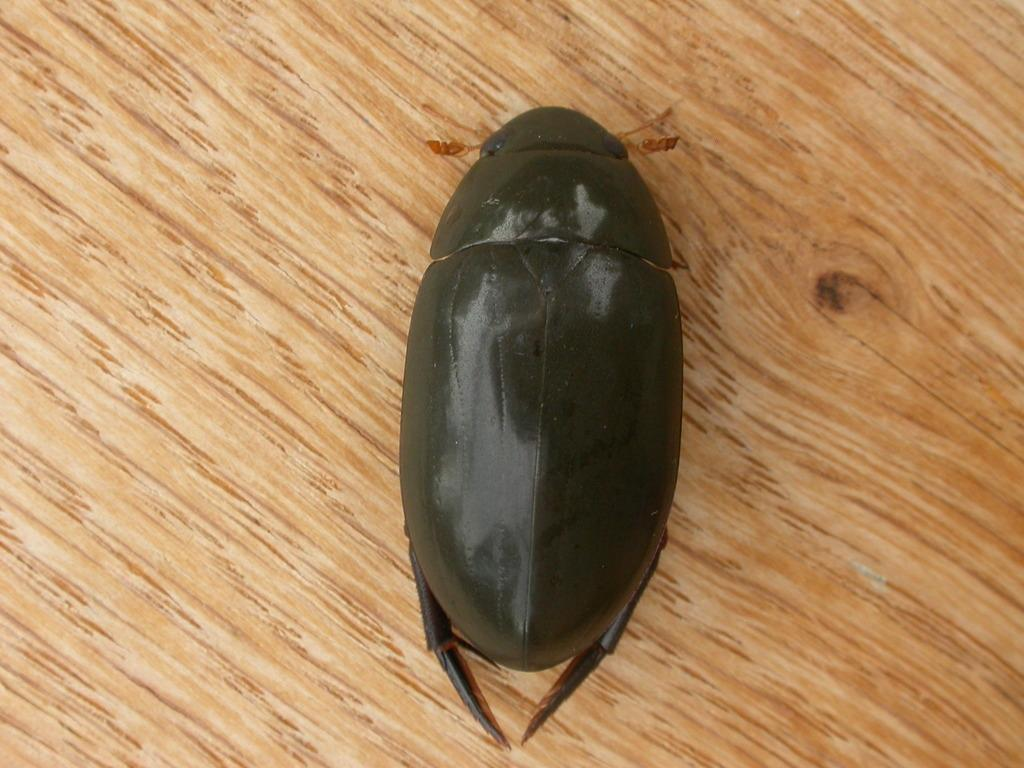What type of creature is in the image? There is a black insect in the image. Where is the insect located? The insect is on a platform. What type of soup is being served in the image? There is no soup present in the image; it features a black insect on a platform. What type of quill is the insect holding in the image? There is no quill present in the image, and the insect is not holding anything. 